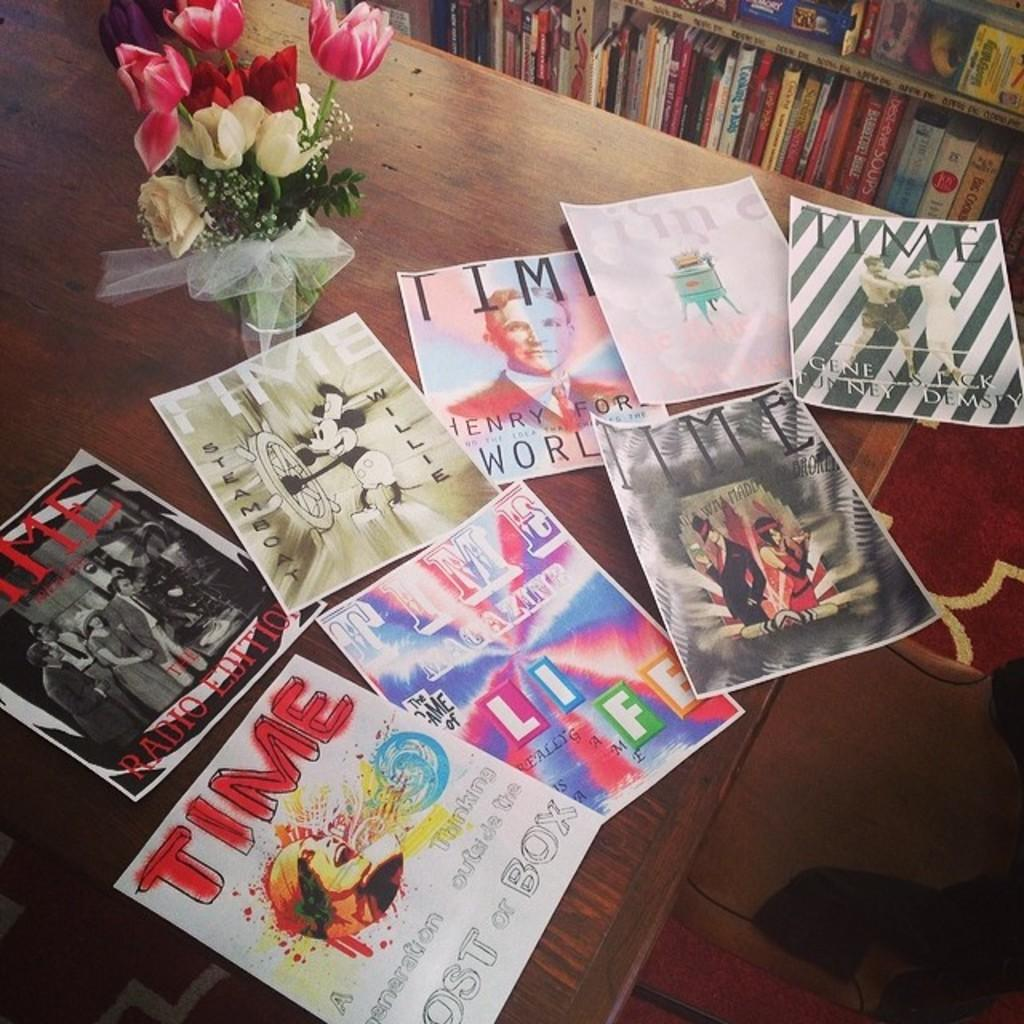Provide a one-sentence caption for the provided image. Scans of old Time Magazine covers lay on a table in front of a vase of tulips. 